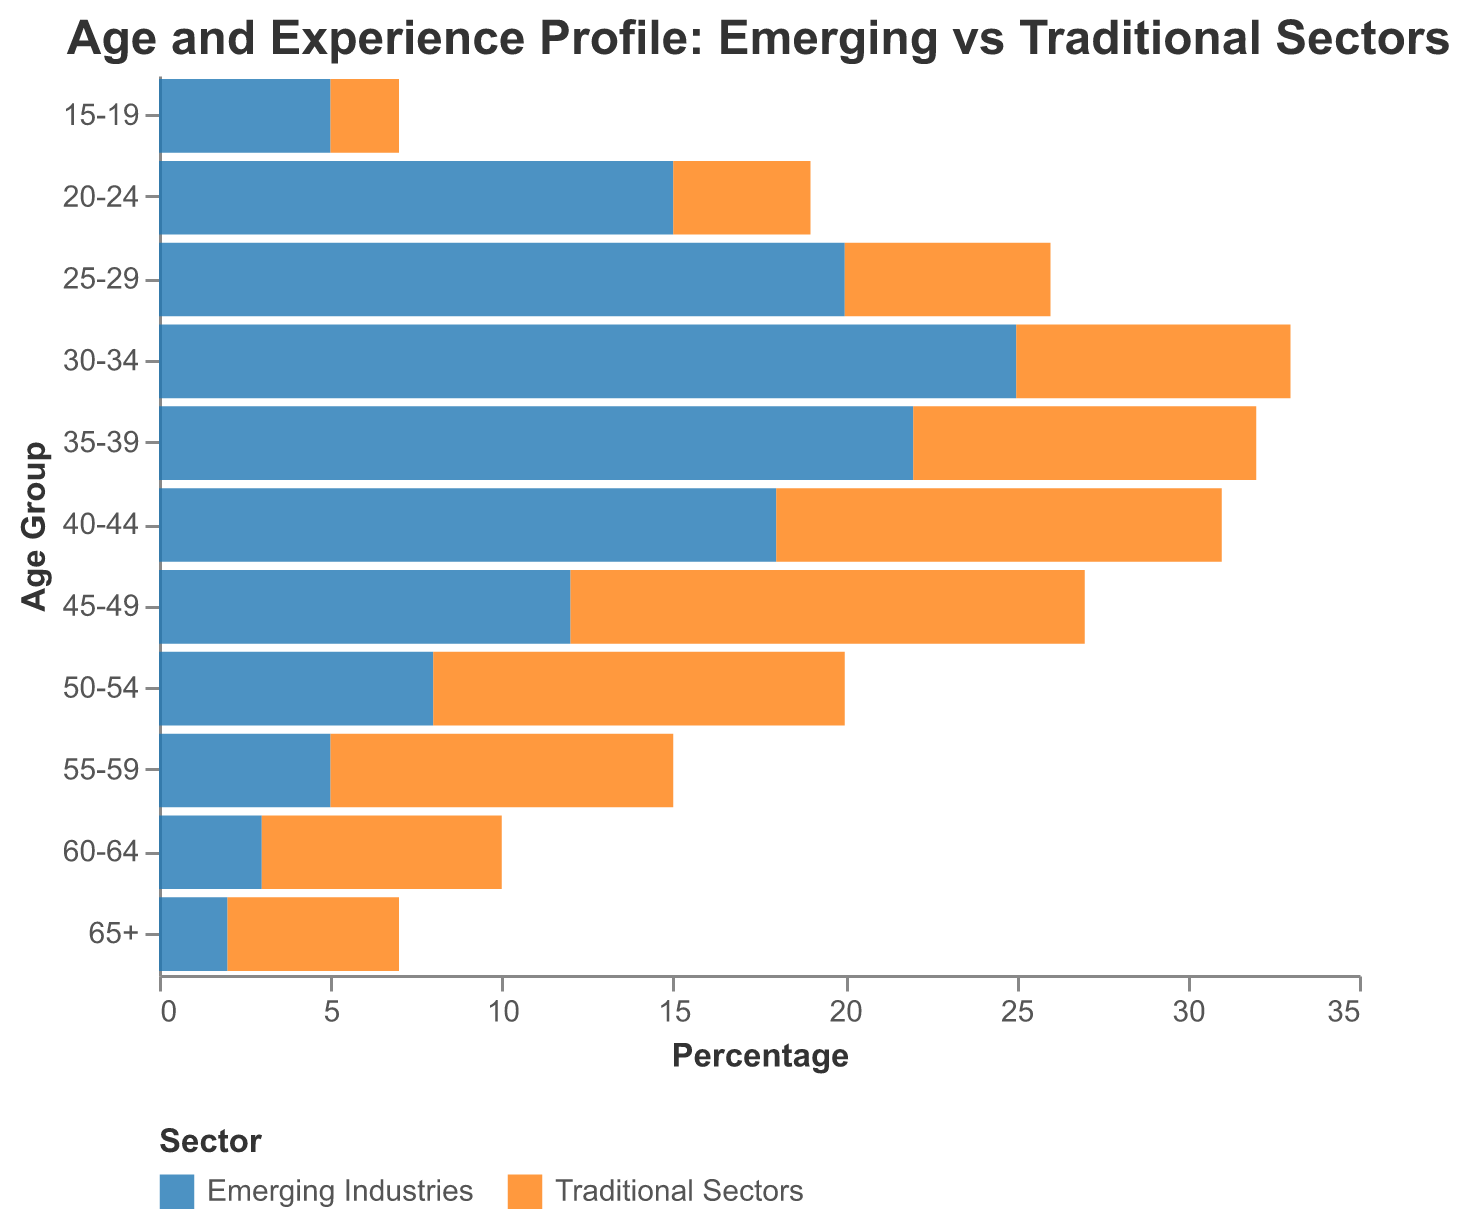What is the title of the chart? The title of the chart is "Age and Experience Profile: Emerging vs Traditional Sectors"
Answer: Age and Experience Profile: Emerging vs Traditional Sectors What age group has the highest value in Traditional Sectors? The data shows that the age group 45-49 has the highest percentage (15) of workers in Traditional Sectors.
Answer: 45-49 Which sector has a larger proportion of younger workers (age group 30-34)? For the age group 30-34, the negative value (-25) indicates that the Emerging Industries have a larger proportion of younger workers compared to the Traditional Sectors (8).
Answer: Emerging Industries How does the proportion of workers aged 20-24 compare between Emerging Industries and Traditional Sectors? By comparing the values, Emerging Industries (-15) have a larger proportion of workers aged 20-24 than Traditional Sectors (4).
Answer: Emerging Industries What is the difference in the number of workers aged 50-54 between Emerging Industries and Traditional Sectors? The proportion of workers aged 50-54 in Emerging Industries is -8, while in Traditional Sectors it is 12. The difference is 12 - (-8) = 20.
Answer: 20 Which age group has a more balanced distribution between the two sectors? By looking at the data, the age group 15-19 has the closest values between the two sectors with Emerging Industries at -5 and Traditional Sectors at 2.
Answer: 15-19 How many age groups have a higher proportion of workers in Emerging Industries compared to Traditional Sectors? By reviewing each age group, the Emerging Industries have a higher proportion in the following age groups: 30-34, 35-39, 40-44, 45-49, 50-54, 55-59, 60-64, 65+. There are 8 age groups in total.
Answer: 8 In what age group does the Traditional Sectors have twice the proportion of workers as the Emerging Industries? For the age group 55-59, Traditional Sectors have 10 while Emerging Industries have -5. Traditional Sectors have twice the proportion.
Answer: 55-59 